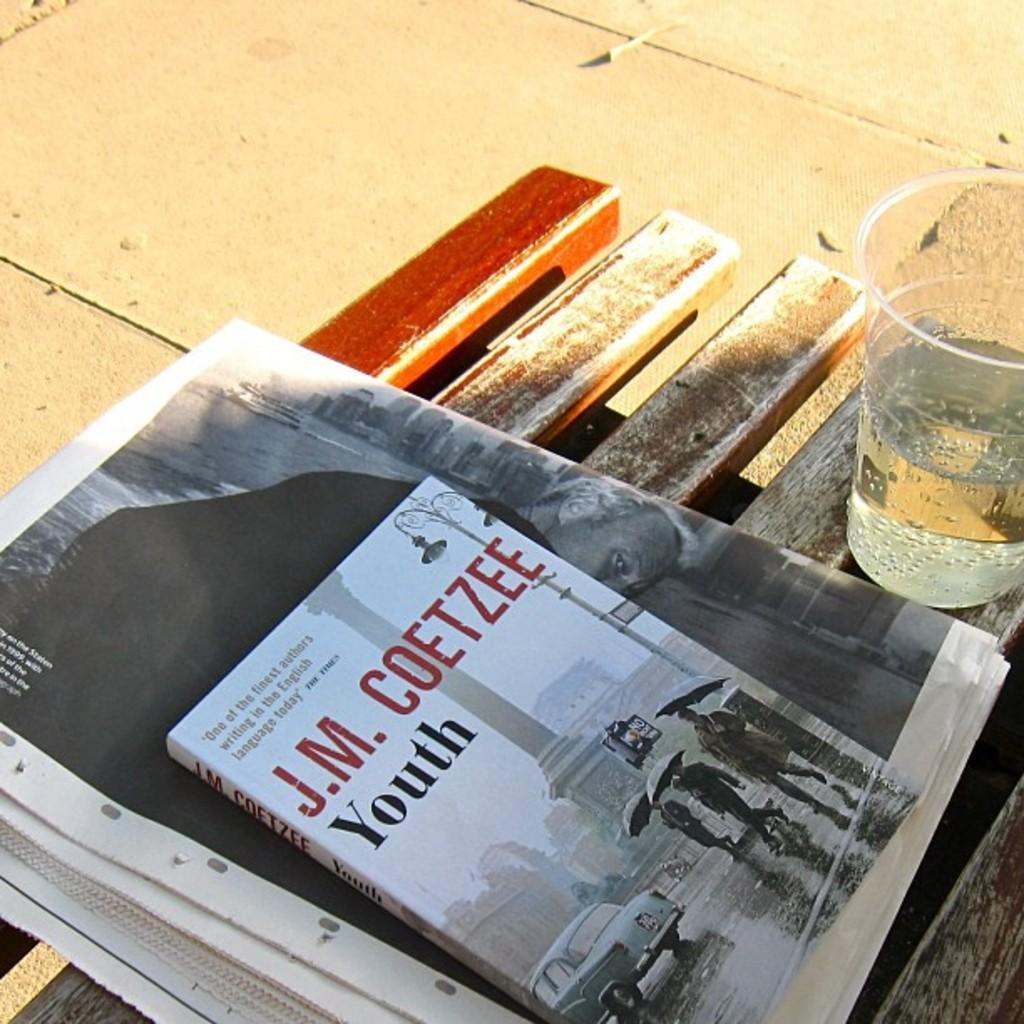<image>
Render a clear and concise summary of the photo. A J.M. Coetzee book sitting on a bench next to plastic cup. 